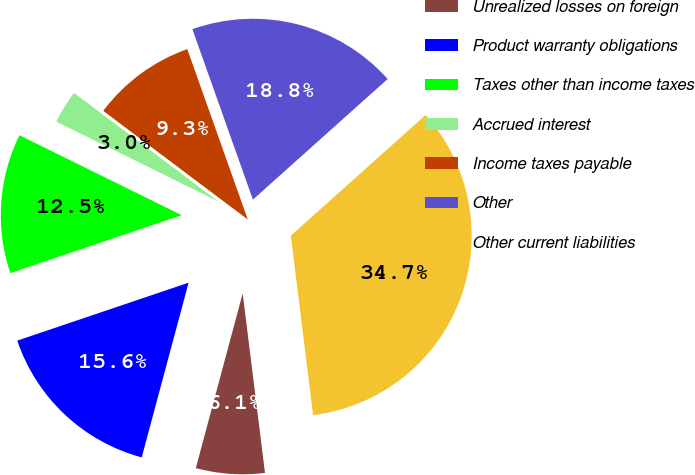<chart> <loc_0><loc_0><loc_500><loc_500><pie_chart><fcel>Unrealized losses on foreign<fcel>Product warranty obligations<fcel>Taxes other than income taxes<fcel>Accrued interest<fcel>Income taxes payable<fcel>Other<fcel>Other current liabilities<nl><fcel>6.14%<fcel>15.64%<fcel>12.48%<fcel>2.97%<fcel>9.31%<fcel>18.81%<fcel>34.66%<nl></chart> 